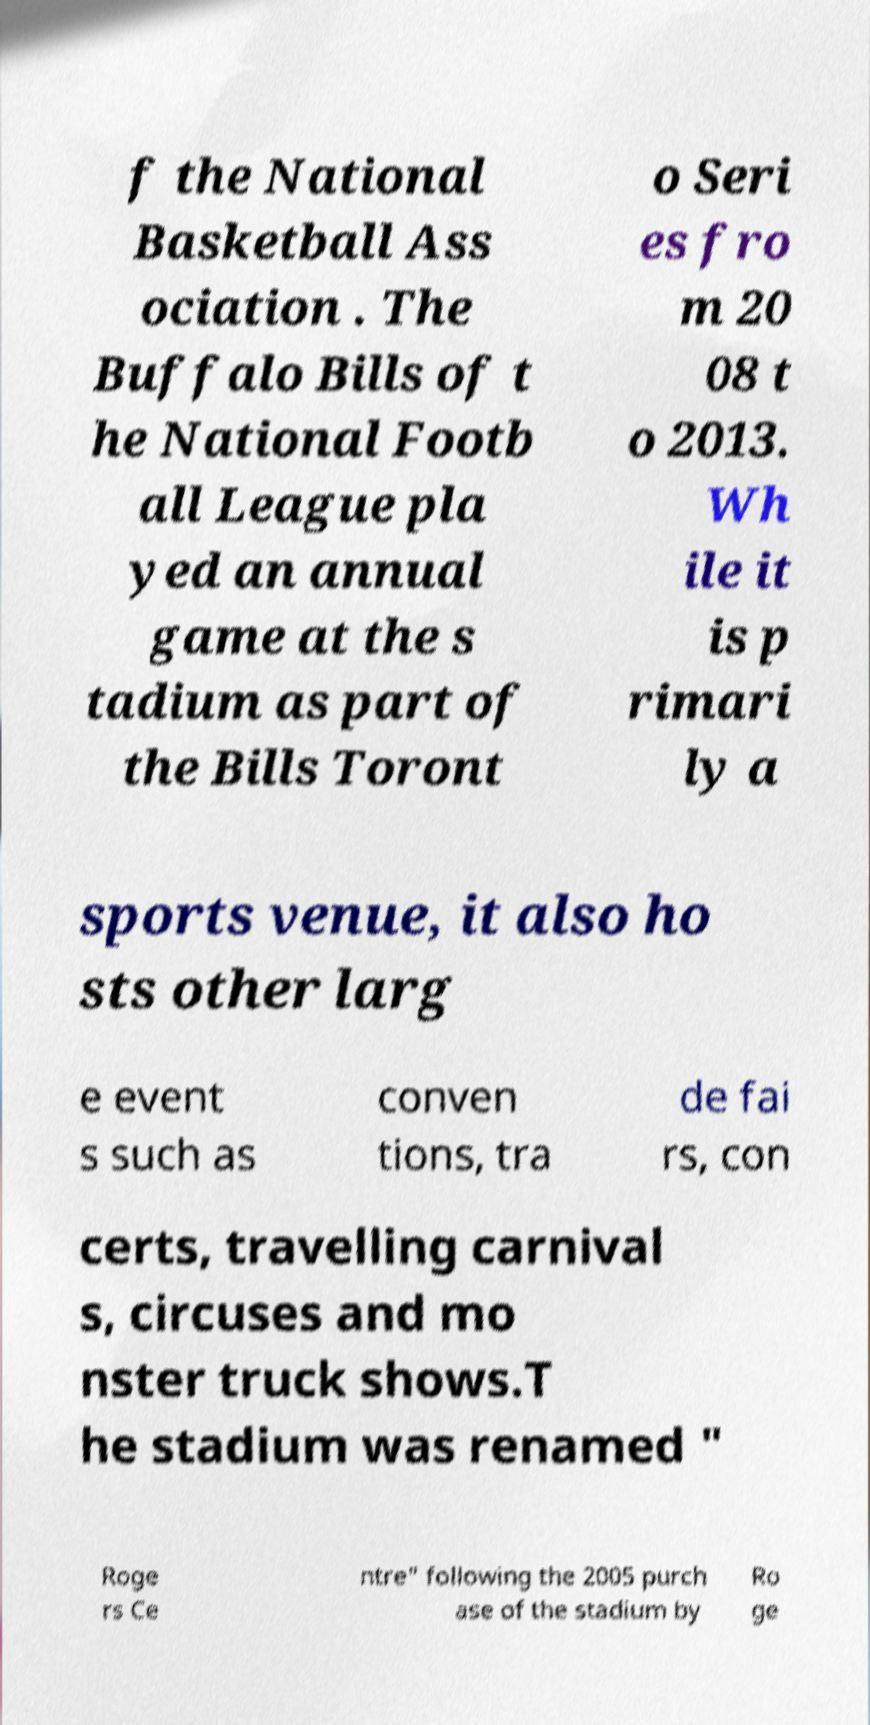There's text embedded in this image that I need extracted. Can you transcribe it verbatim? f the National Basketball Ass ociation . The Buffalo Bills of t he National Footb all League pla yed an annual game at the s tadium as part of the Bills Toront o Seri es fro m 20 08 t o 2013. Wh ile it is p rimari ly a sports venue, it also ho sts other larg e event s such as conven tions, tra de fai rs, con certs, travelling carnival s, circuses and mo nster truck shows.T he stadium was renamed " Roge rs Ce ntre" following the 2005 purch ase of the stadium by Ro ge 